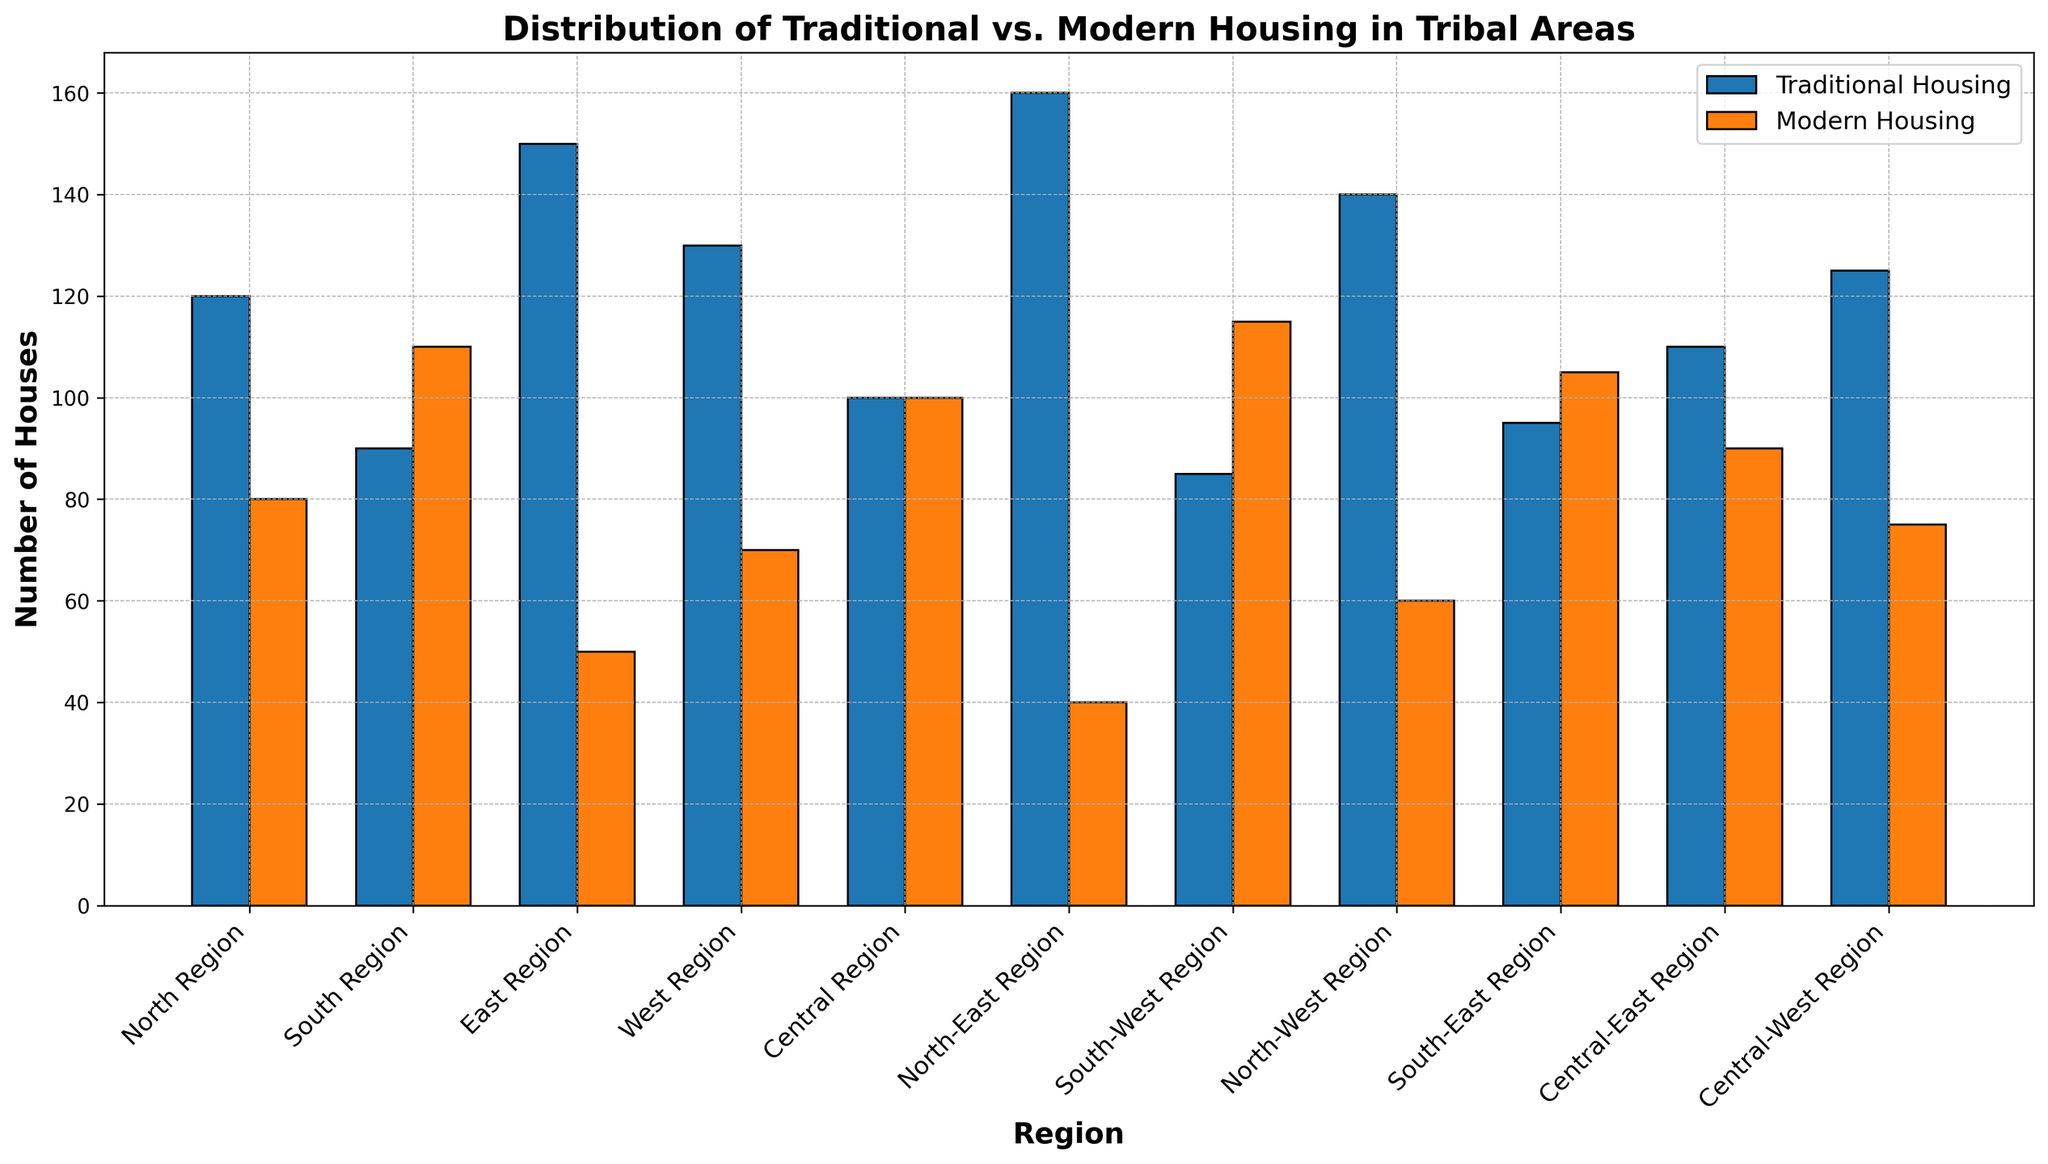Which region has the highest number of traditional houses? By looking at the bars representing traditional housing, the North-East Region has the tallest bar indicating it has the most traditional houses.
Answer: North-East Region Which region has the highest number of modern houses? By observing the bars representing modern housing, the South-West Region has the tallest bar indicating it has the highest modern houses.
Answer: South-West Region Which region has an equal number of traditional and modern houses? The Central Region has bars of equal height for both traditional and modern housing.
Answer: Central Region Which region shows the biggest difference between traditional and modern housing counts? The North-East Region shows a significant difference with 160 traditional houses compared to 40 modern houses, a difference of 120.
Answer: North-East Region What's the average number of traditional houses across all regions? Summing up the traditional houses counts (120+90+150+130+100+160+85+140+95+110+125) gives 1305. Dividing by 11 regions, the average is 1305/11 ≈ 118.64.
Answer: approximately 118.64 Which two regions have the smallest and largest numbers of modern houses, respectively? The smallest count of modern houses is in the North-East Region (40), and the largest is in the South-West Region (115).
Answer: North-East Region, South-West Region What percentage of houses in the North Region are traditional? The North Region has 120 traditional and 80 modern houses. The total is 120 + 80 = 200 houses. The percentage is (120/200) * 100 = 60%.
Answer: 60% Compare the number of modern houses in the Central-East Region to the number of traditional houses in the South Region. Which is greater? The Central-East Region has 90 modern houses, whereas the South Region has 90 traditional houses. Both counts are equal.
Answer: They are equal In which region is the sum of traditional and modern houses the greatest? Adding the counts for each region, the North-East Region has the highest sum: 160 (traditional) + 40 (modern) = 200 houses.
Answer: North-East Region What’s the difference in the number of traditional houses between the West and Central-West Regions? The West Region has 130 traditional houses, and the Central-West Region has 125. The difference is 130 - 125 = 5.
Answer: 5 